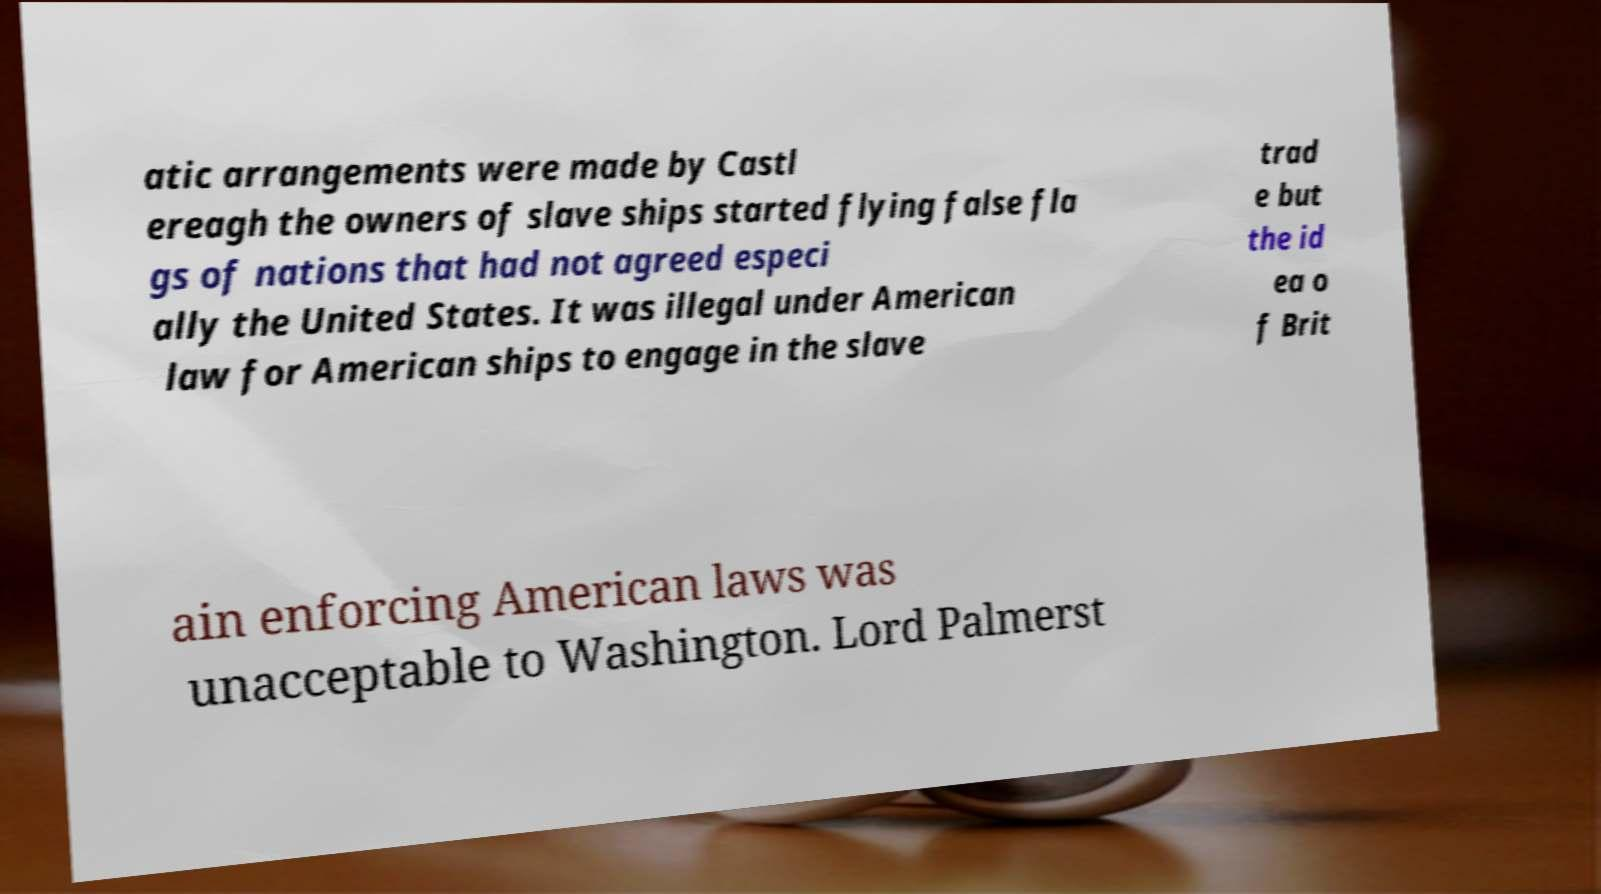Please identify and transcribe the text found in this image. atic arrangements were made by Castl ereagh the owners of slave ships started flying false fla gs of nations that had not agreed especi ally the United States. It was illegal under American law for American ships to engage in the slave trad e but the id ea o f Brit ain enforcing American laws was unacceptable to Washington. Lord Palmerst 